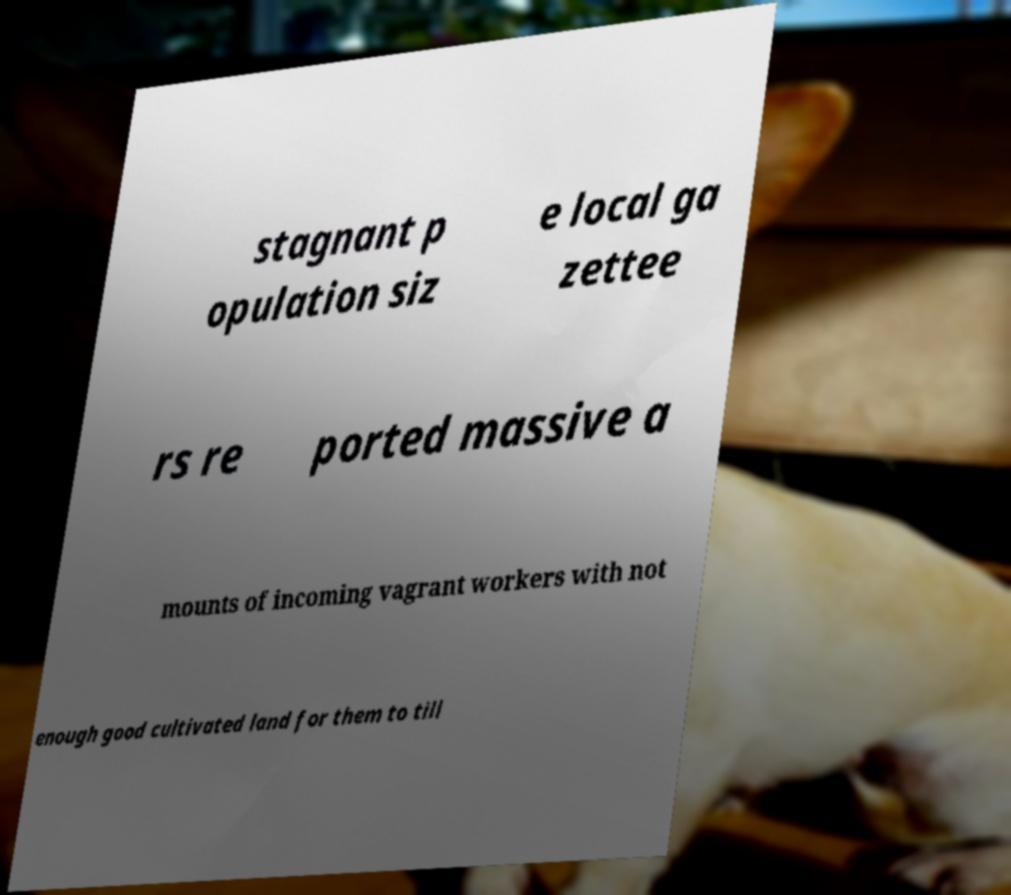Please identify and transcribe the text found in this image. stagnant p opulation siz e local ga zettee rs re ported massive a mounts of incoming vagrant workers with not enough good cultivated land for them to till 